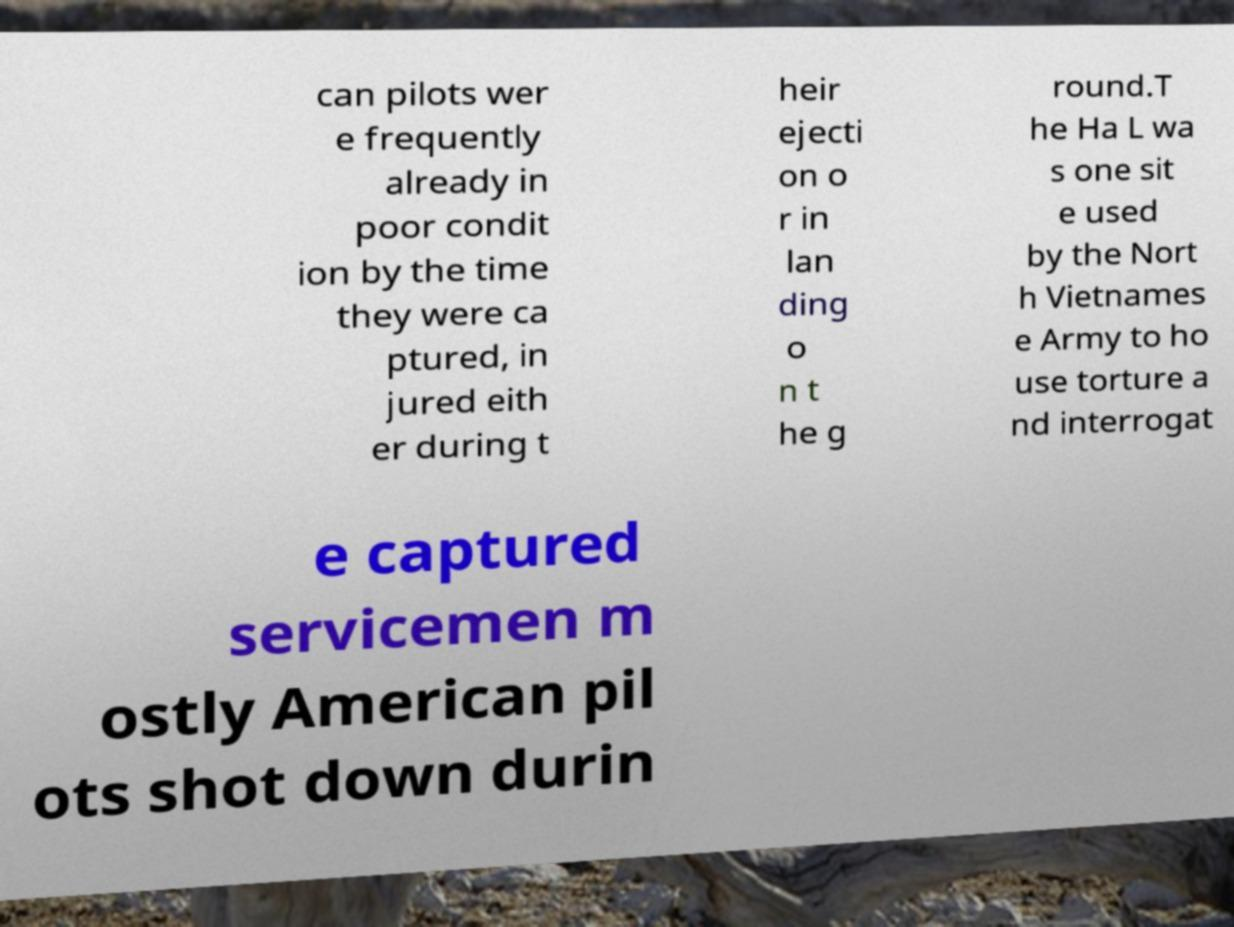There's text embedded in this image that I need extracted. Can you transcribe it verbatim? can pilots wer e frequently already in poor condit ion by the time they were ca ptured, in jured eith er during t heir ejecti on o r in lan ding o n t he g round.T he Ha L wa s one sit e used by the Nort h Vietnames e Army to ho use torture a nd interrogat e captured servicemen m ostly American pil ots shot down durin 